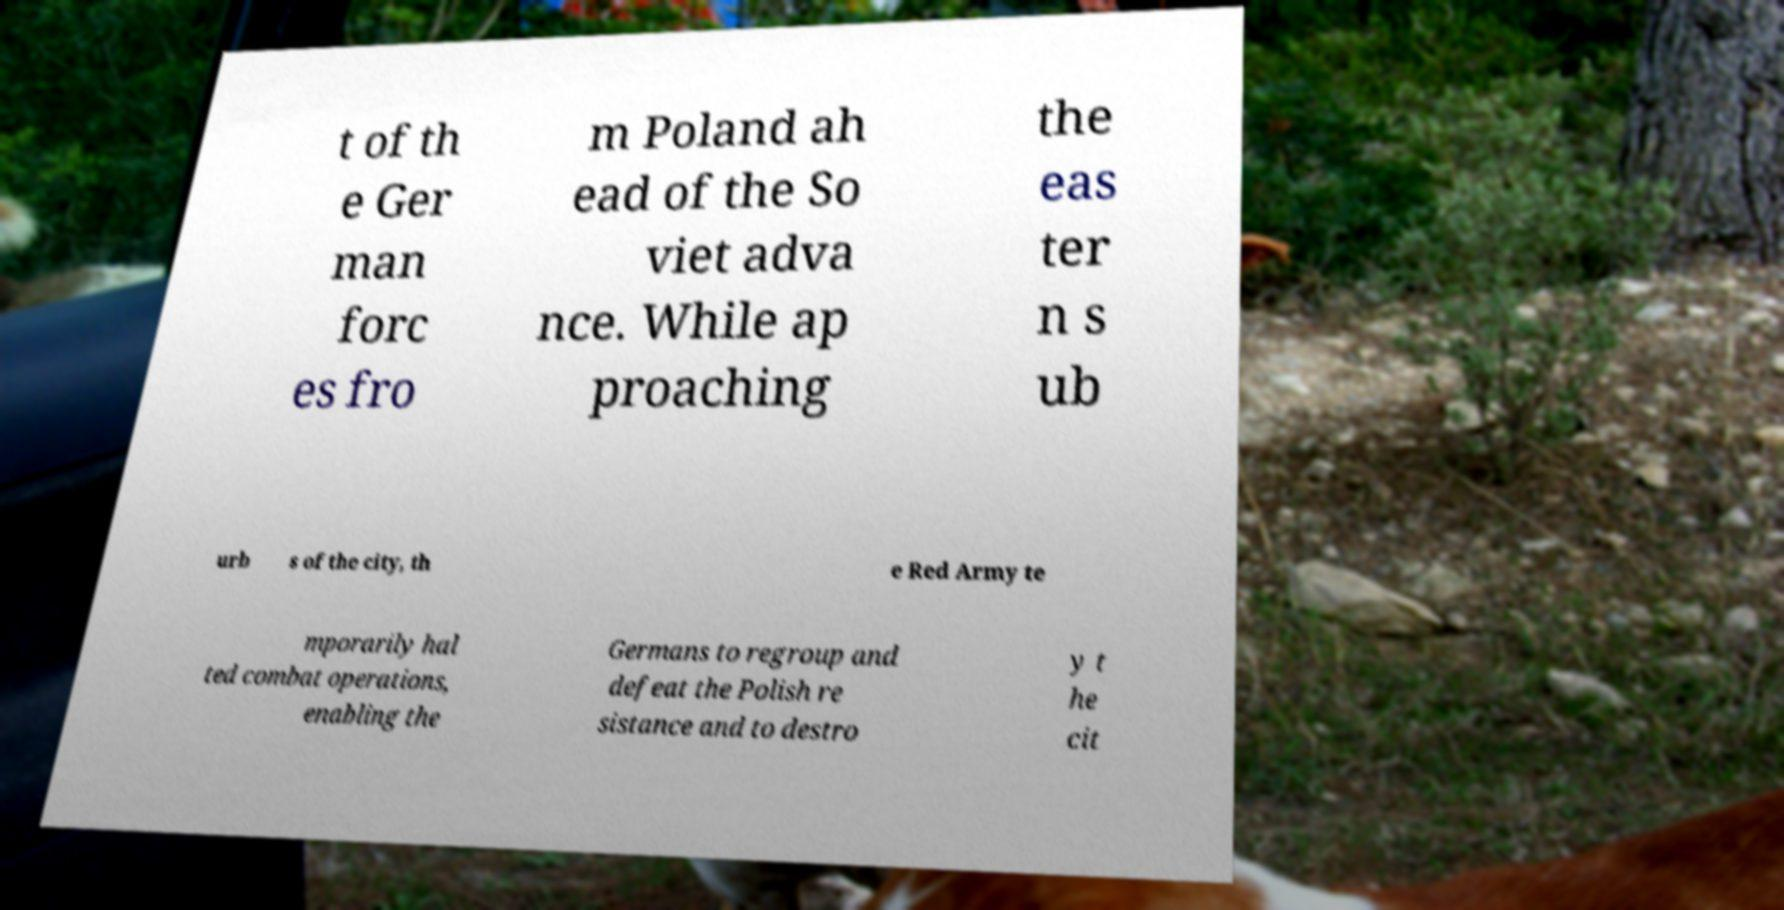There's text embedded in this image that I need extracted. Can you transcribe it verbatim? t of th e Ger man forc es fro m Poland ah ead of the So viet adva nce. While ap proaching the eas ter n s ub urb s of the city, th e Red Army te mporarily hal ted combat operations, enabling the Germans to regroup and defeat the Polish re sistance and to destro y t he cit 